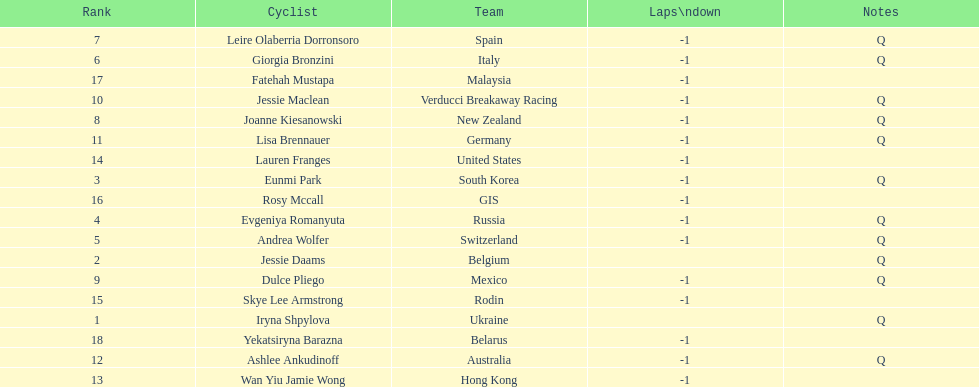What team is listed previous to belgium? Ukraine. 